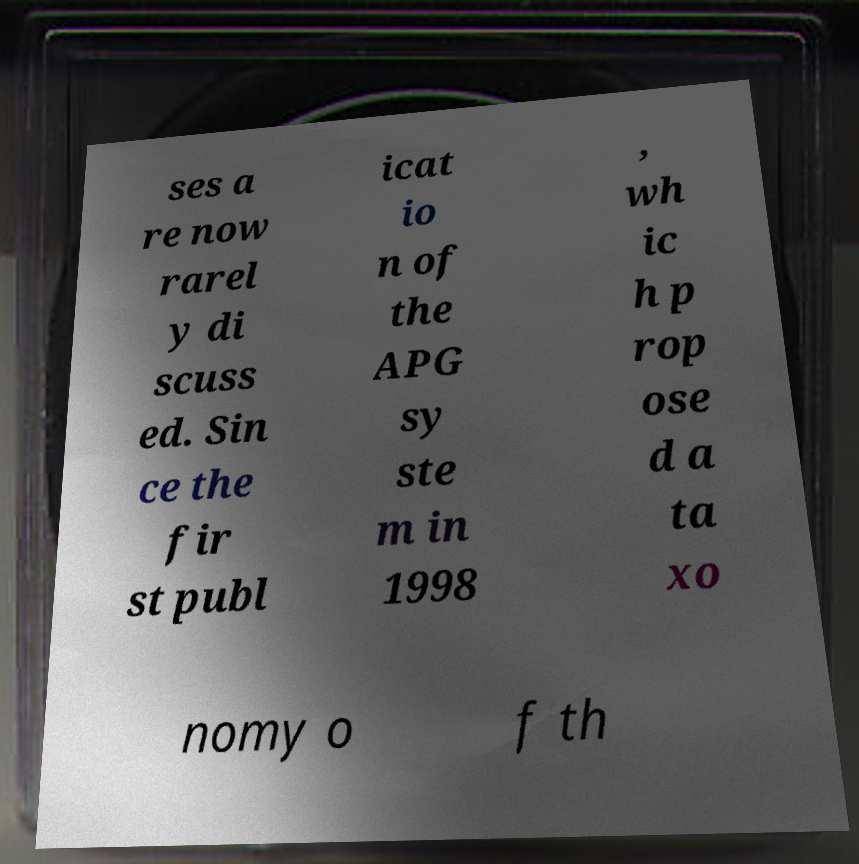Could you assist in decoding the text presented in this image and type it out clearly? ses a re now rarel y di scuss ed. Sin ce the fir st publ icat io n of the APG sy ste m in 1998 , wh ic h p rop ose d a ta xo nomy o f th 